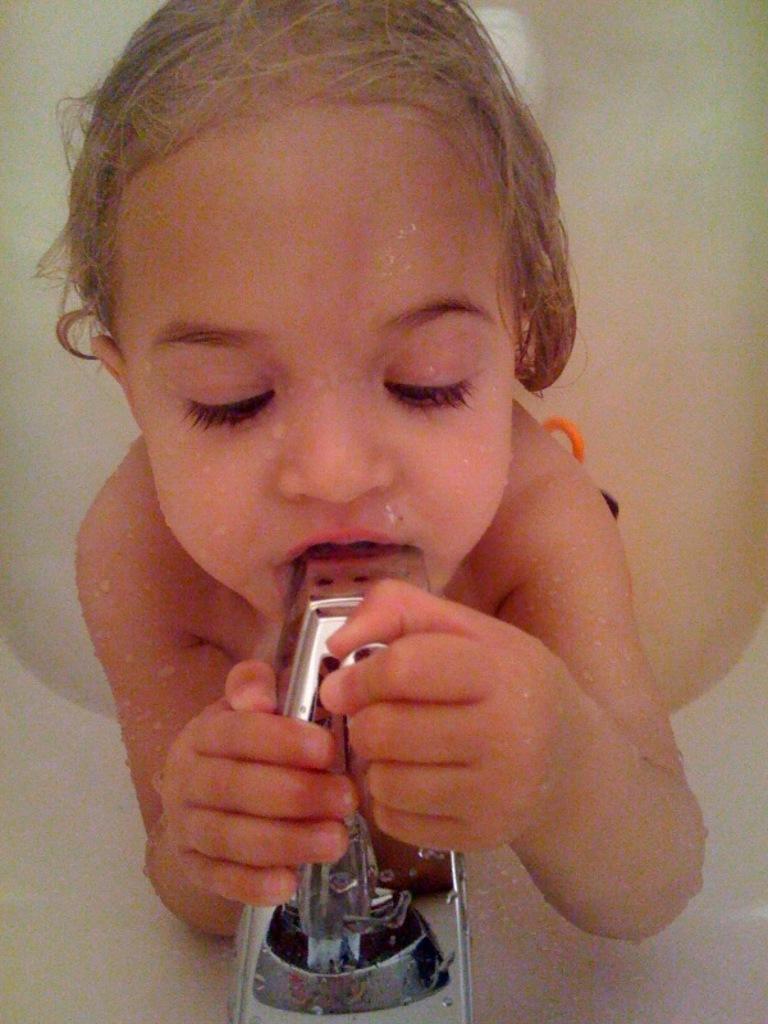Could you give a brief overview of what you see in this image? Here I can see a baby is holding a tap with hands and mouth. 